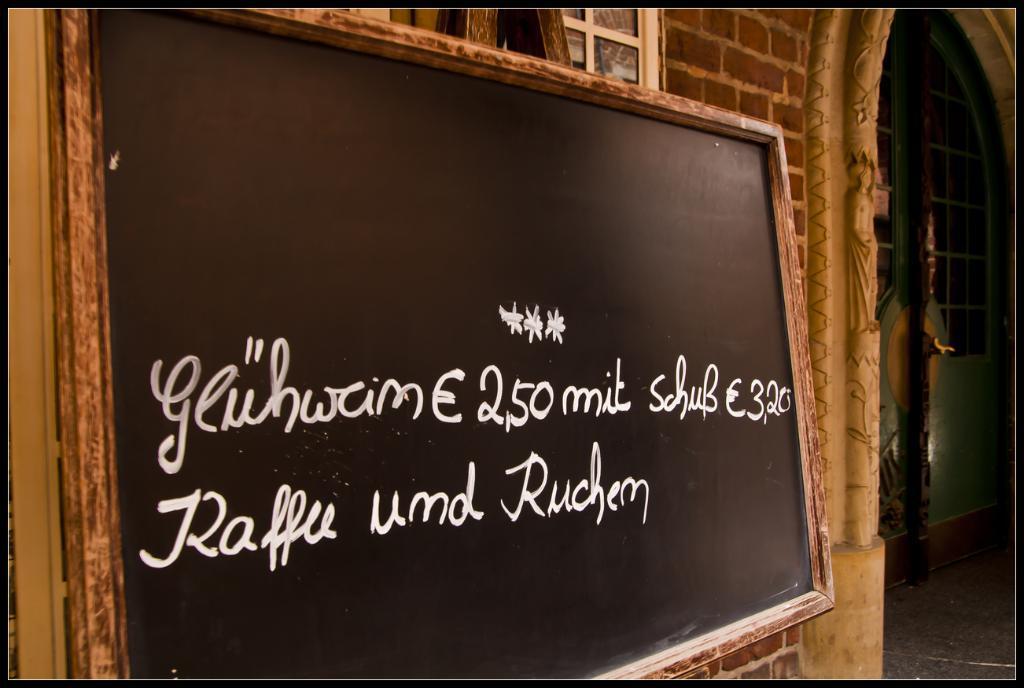Describe this image in one or two sentences. This is a blackboard with the letters on it, which is attached to the wall. I think this is an arch. This looks like a sculpture on the wall. I think this is a door with a door handle. 